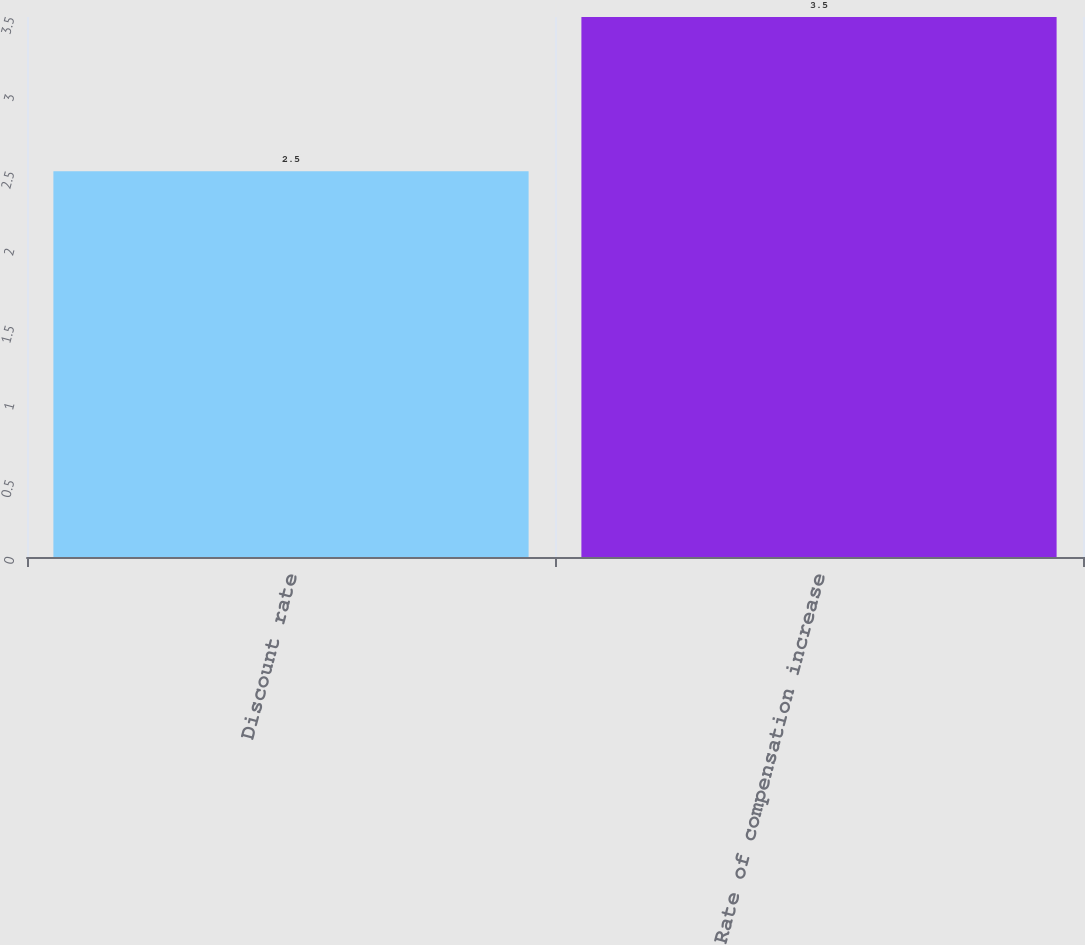Convert chart. <chart><loc_0><loc_0><loc_500><loc_500><bar_chart><fcel>Discount rate<fcel>Rate of compensation increase<nl><fcel>2.5<fcel>3.5<nl></chart> 